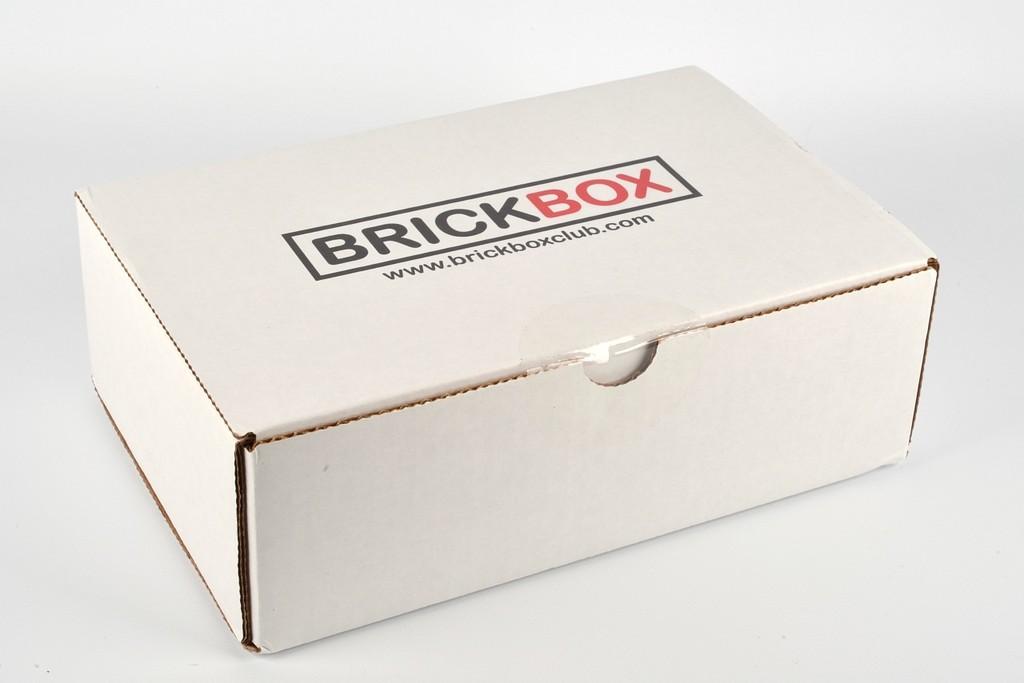What is the name of this box?
Your answer should be compact. Brickbox. What website is shown under the logo?
Your answer should be very brief. Www.brickboxclub.com. 